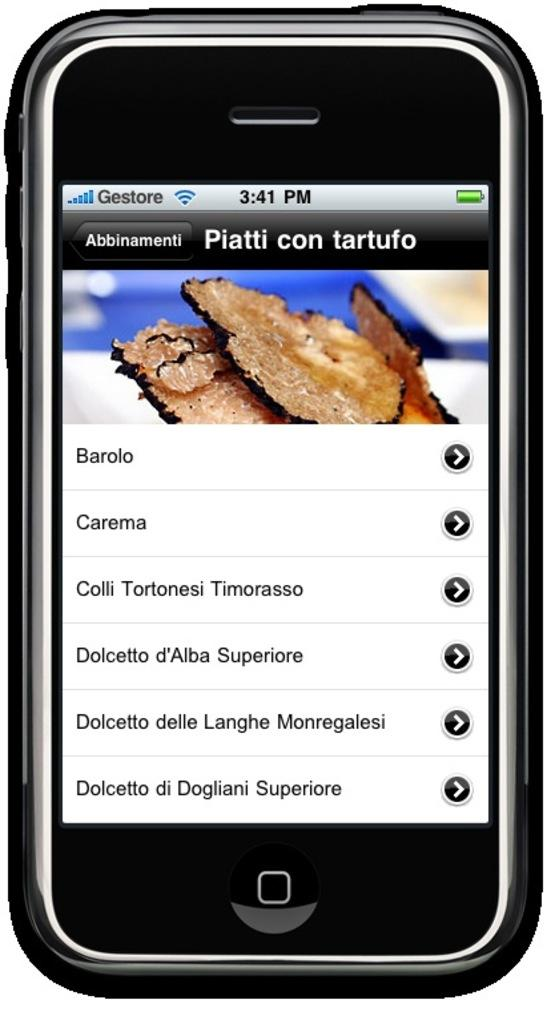<image>
Share a concise interpretation of the image provided. The cell phone is open to a website called Piatti con tarfuto. 